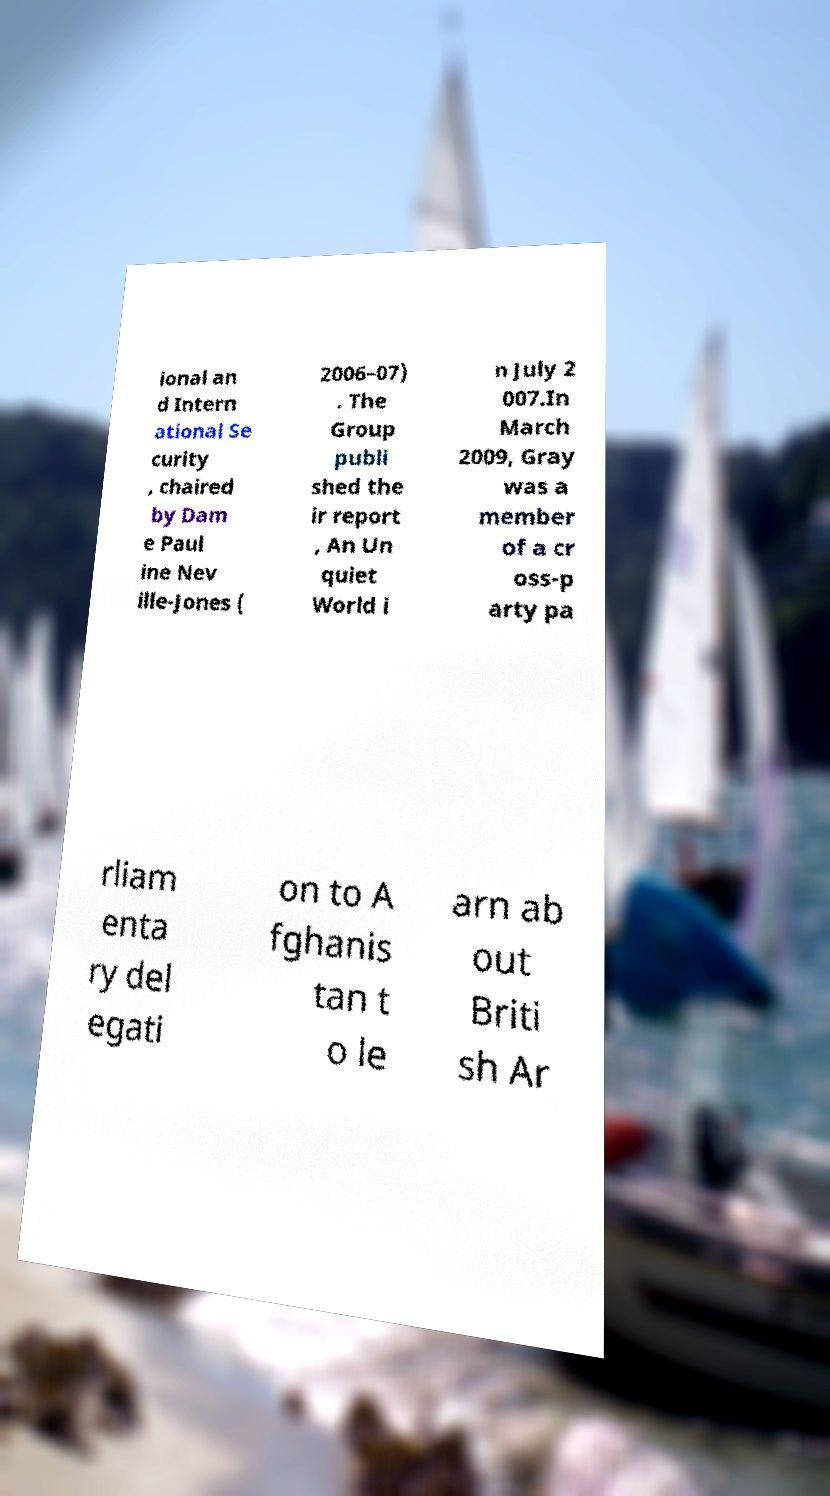Could you assist in decoding the text presented in this image and type it out clearly? ional an d Intern ational Se curity , chaired by Dam e Paul ine Nev ille-Jones ( 2006–07) . The Group publi shed the ir report , An Un quiet World i n July 2 007.In March 2009, Gray was a member of a cr oss-p arty pa rliam enta ry del egati on to A fghanis tan t o le arn ab out Briti sh Ar 